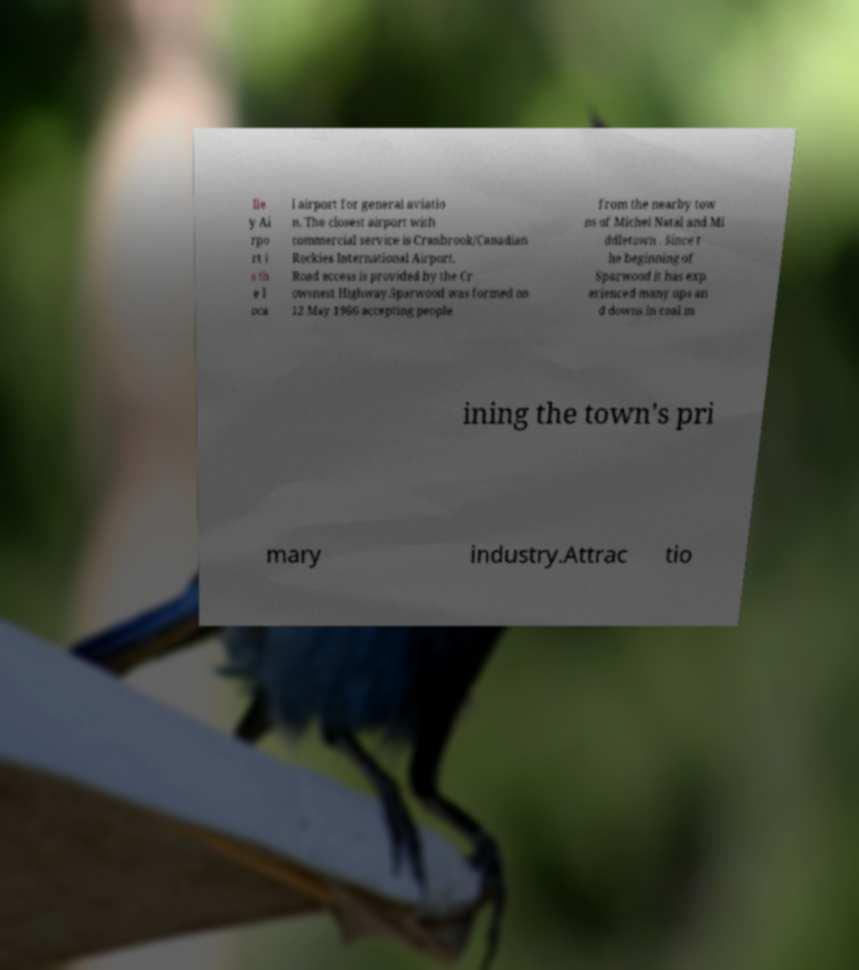Can you accurately transcribe the text from the provided image for me? lle y Ai rpo rt i s th e l oca l airport for general aviatio n. The closest airport with commercial service is Cranbrook/Canadian Rockies International Airport. Road access is provided by the Cr owsnest Highway.Sparwood was formed on 12 May 1966 accepting people from the nearby tow ns of Michel Natal and Mi ddletown . Since t he beginning of Sparwood it has exp erienced many ups an d downs in coal m ining the town's pri mary industry.Attrac tio 